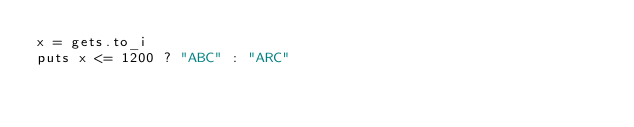<code> <loc_0><loc_0><loc_500><loc_500><_Ruby_>x = gets.to_i
puts x <= 1200 ? "ABC" : "ARC"
</code> 